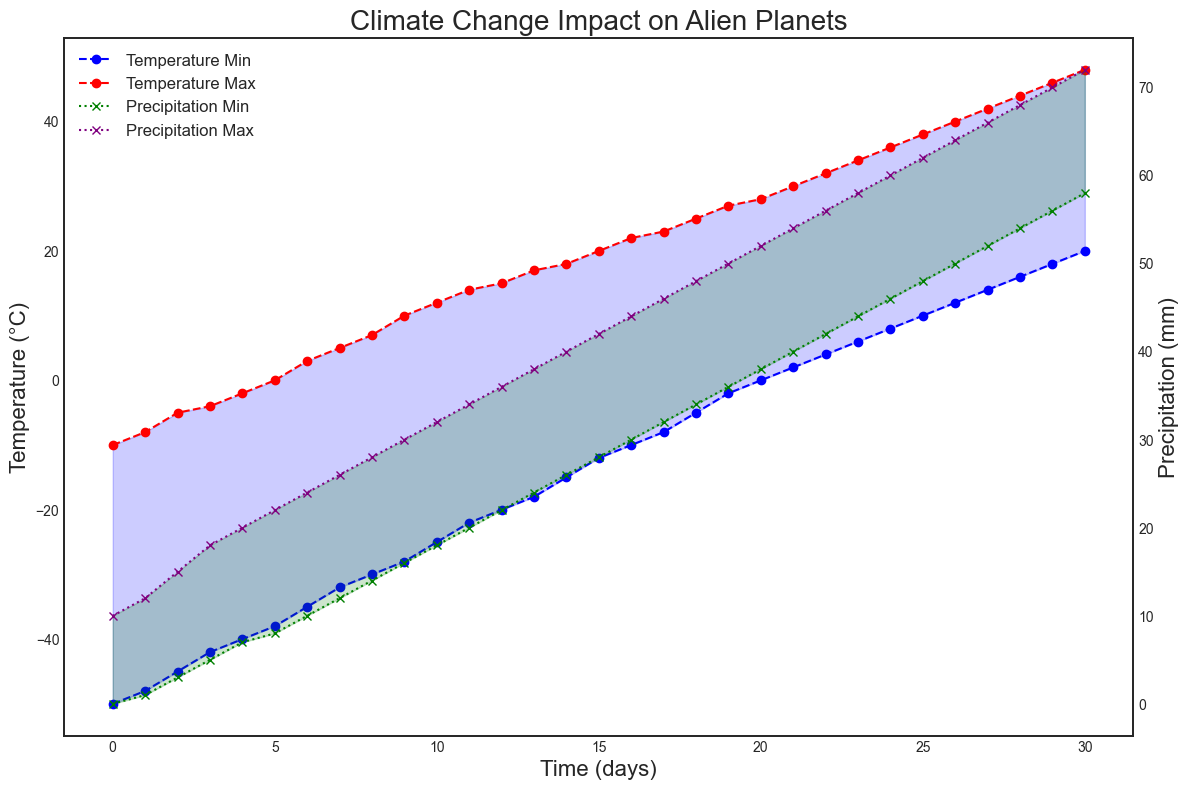What is the maximum temperature range observed in the data? The maximum temperature range can be found by looking at the highest difference between the temperature_max and temperature_min values in the figure. At time index 30, the temperature_max is 48°C and the temperature_min is 20°C. The range is 48 - 20 = 28°C.
Answer: 28°C Compare the general trend of temperature and precipitation over time. Are they both increasing? By observing the upward slope of both the temperature and precipitation lines over time, it's clear that both temperature and precipitation are increasing over the 30-day period represented in the figure.
Answer: Yes At which time index does the temperature_min reach 0°C? By checking the values plotted on the figure, we see that at time index 20, the temperature_min is 0°C.
Answer: 20 What is the temperature difference between day 10 and day 20? From the figure, the temperature_min on day 10 is -25°C and on day 20 it is 0°C. The temperature_max on day 10 is 12°C and on day 20 it is 28°C. So, the temperature difference is calculated as: (28 - 0) - (12 - (-25)) = 28 + 25 - 12 = 41°C.
Answer: 41°C On what day is the difference between precipitation_max and precipitation_min the greatest? The difference between precipitation_max and precipitation_min can be seen as the height of the filled area in the precipitation plot. Looking at the figure, the difference appears to be the greatest on day 30 where precipitation_max is 72mm and precipitation_min is 58mm, making the difference 72 - 58 = 14mm.
Answer: Day 30 On which day do both the temperature_max and precipitation_max first exceed 30°C and 50mm, respectively? Observing the chart, temperature_max exceeds 30°C and precipitation_max exceeds 50mm on day 19.
Answer: Day 19 Is there a day where the precipitation_min is consistently above 20mm? By looking at the precipitation_min line in the figure, we can see that it starts to stay above 20mm from day 12 onward.
Answer: Day 12 and onwards What is the range of precipitation values on day 15? On day 15, precipitation_min is 28mm and precipitation_max is 42mm. Therefore, the range is 42 - 28 = 14mm.
Answer: 14mm 